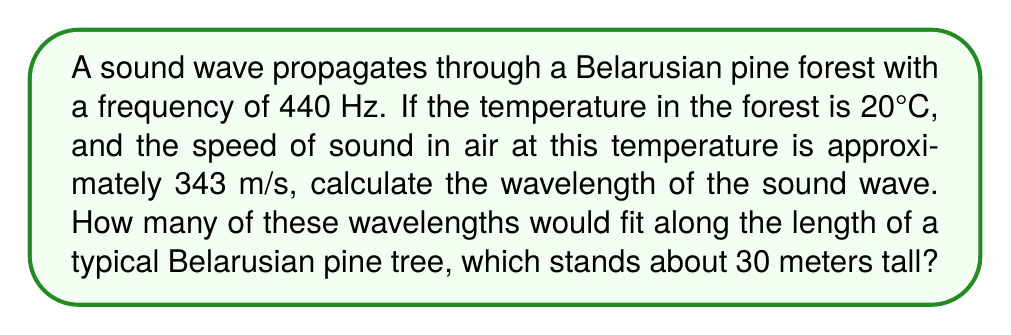Can you answer this question? 1. To find the wavelength, we use the wave equation:
   $$v = f\lambda$$
   where $v$ is the speed of sound, $f$ is the frequency, and $\lambda$ is the wavelength.

2. Rearranging the equation to solve for $\lambda$:
   $$\lambda = \frac{v}{f}$$

3. Substituting the given values:
   $$\lambda = \frac{343 \text{ m/s}}{440 \text{ Hz}} = 0.78 \text{ m}$$

4. To find how many wavelengths fit along the tree:
   $$\text{Number of wavelengths} = \frac{\text{Tree height}}{\text{Wavelength}}$$

5. Substituting the values:
   $$\text{Number of wavelengths} = \frac{30 \text{ m}}{0.78 \text{ m}} \approx 38.46$$

6. Rounding down to the nearest whole number (as we can't have a partial wavelength):
   $$\text{Number of wavelengths} = 38$$
Answer: 38 wavelengths 